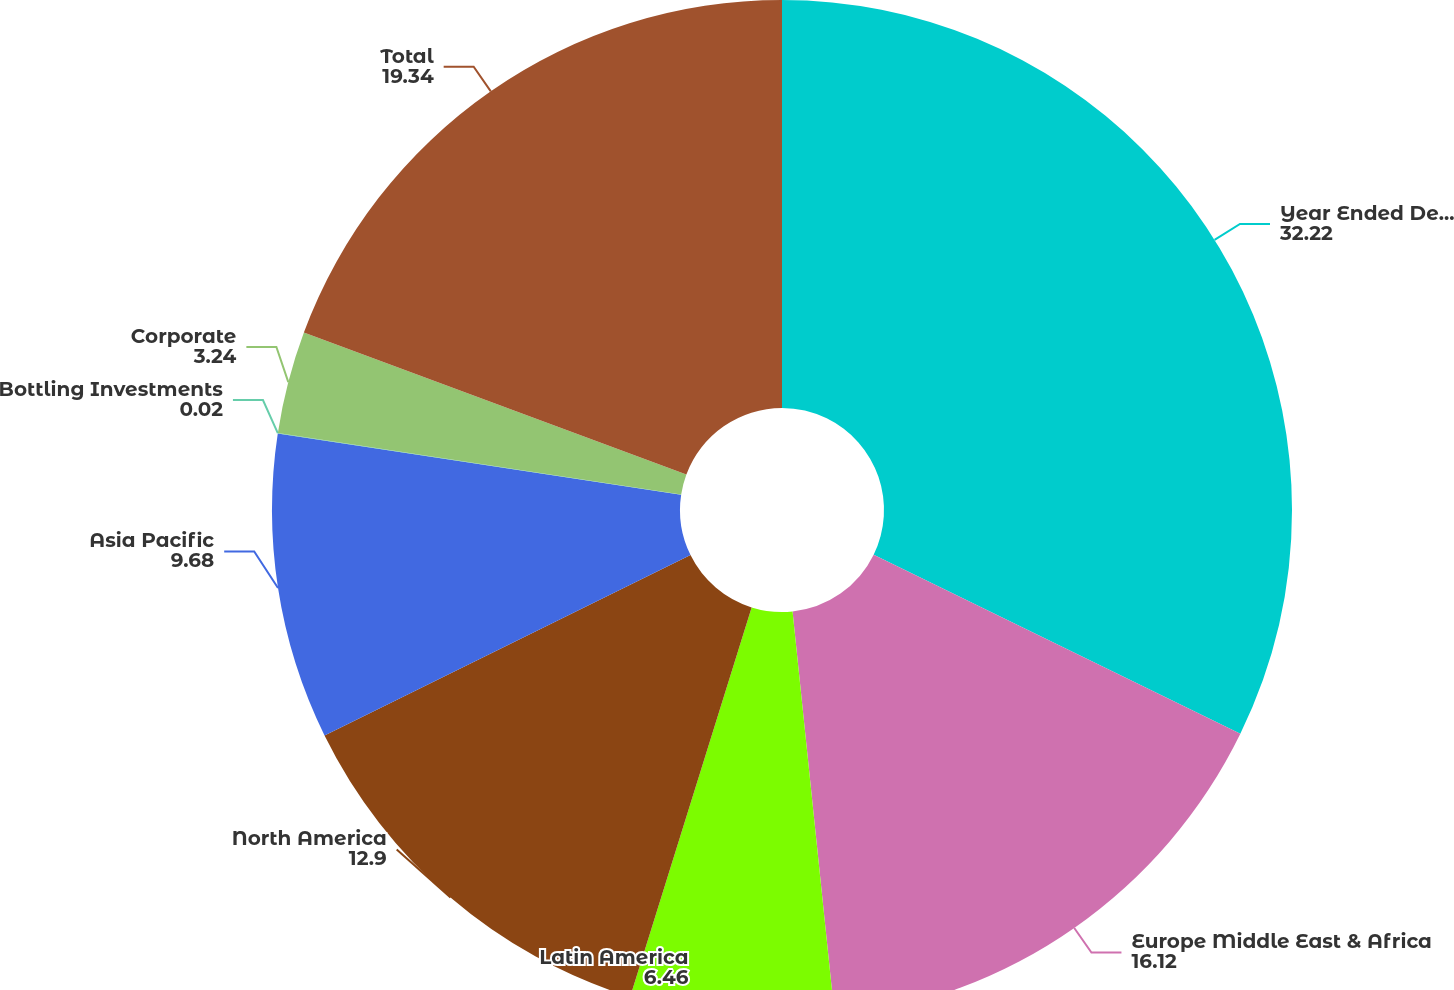Convert chart to OTSL. <chart><loc_0><loc_0><loc_500><loc_500><pie_chart><fcel>Year Ended December 31<fcel>Europe Middle East & Africa<fcel>Latin America<fcel>North America<fcel>Asia Pacific<fcel>Bottling Investments<fcel>Corporate<fcel>Total<nl><fcel>32.22%<fcel>16.12%<fcel>6.46%<fcel>12.9%<fcel>9.68%<fcel>0.02%<fcel>3.24%<fcel>19.34%<nl></chart> 